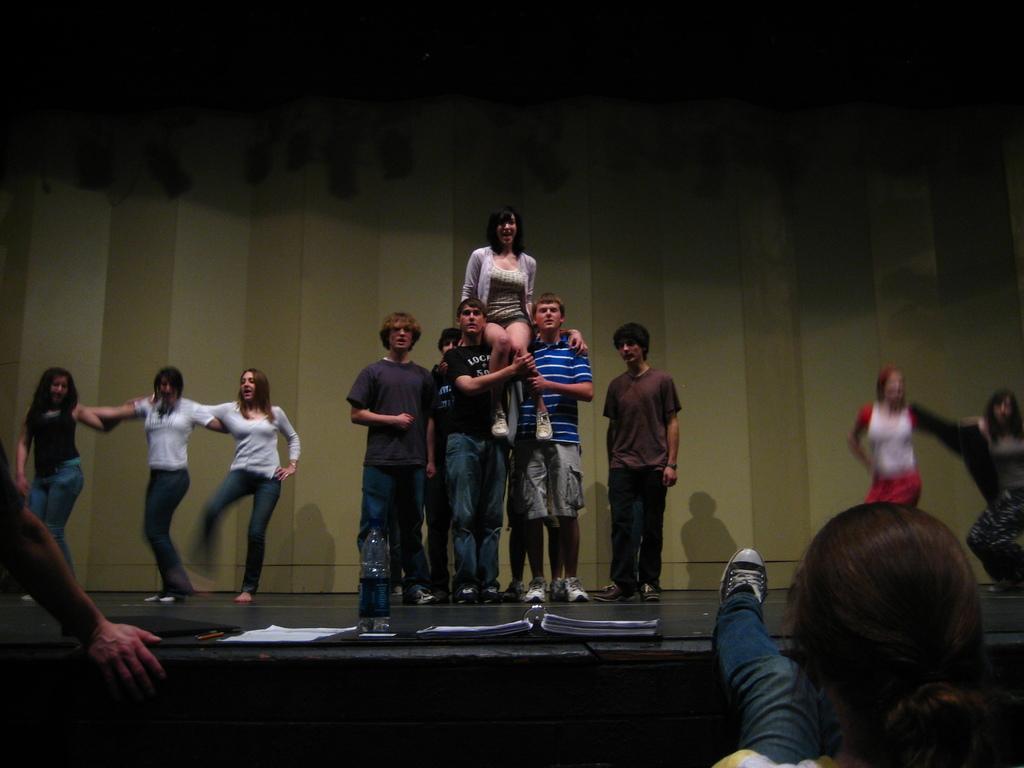Can you describe this image briefly? In this picture we can see some people are standing and some people are dancing on the stage, we can see two persons in the front, there are some papers and a bottle on the stage. 